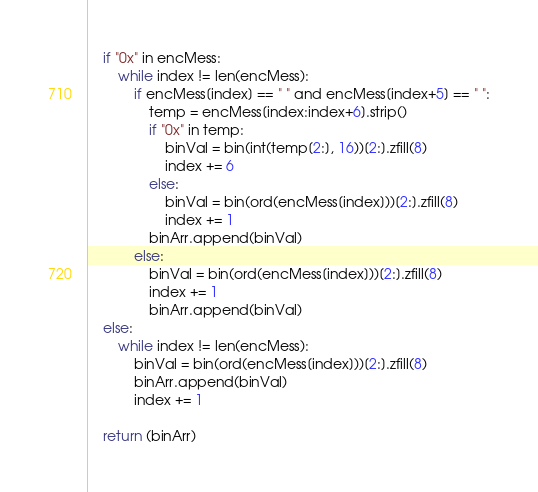Convert code to text. <code><loc_0><loc_0><loc_500><loc_500><_Python_>
    if "0x" in encMess:
        while index != len(encMess):
            if encMess[index] == " " and encMess[index+5] == " ":
                temp = encMess[index:index+6].strip()
                if "0x" in temp:
                    binVal = bin(int(temp[2:], 16))[2:].zfill(8)
                    index += 6
                else:
                    binVal = bin(ord(encMess[index]))[2:].zfill(8)
                    index += 1
                binArr.append(binVal)
            else:
                binVal = bin(ord(encMess[index]))[2:].zfill(8)
                index += 1
                binArr.append(binVal)
    else:
        while index != len(encMess):
            binVal = bin(ord(encMess[index]))[2:].zfill(8)
            binArr.append(binVal)
            index += 1

    return (binArr)</code> 